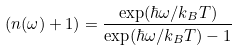Convert formula to latex. <formula><loc_0><loc_0><loc_500><loc_500>( n ( \omega ) + 1 ) = \frac { \exp ( \hbar { \omega } / k _ { B } T ) } { \exp ( \hbar { \omega } / k _ { B } T ) - 1 }</formula> 